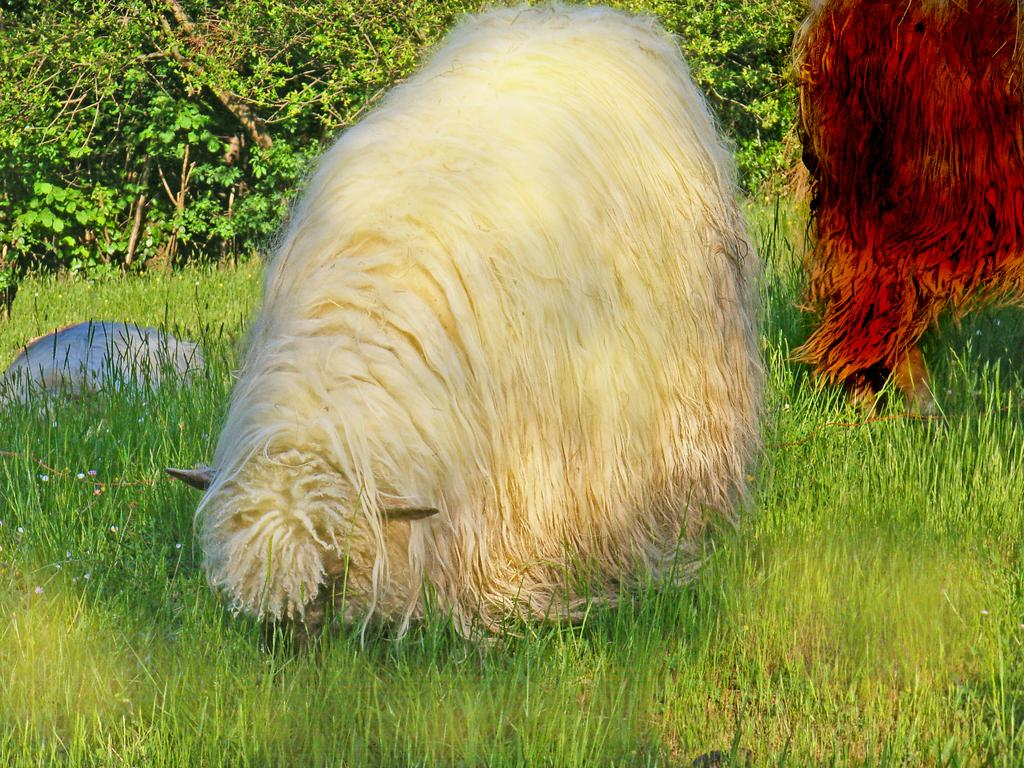What type of animals can be seen on the grass in the image? The image shows animals on the surface of the grass, but the specific type of animals cannot be determined from the provided facts. What can be seen in the background of the image? There are trees in the background of the image. What type of quill is being used to write on the sheet in the image? There is no quill, sheet, or writing activity present in the image. 